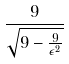Convert formula to latex. <formula><loc_0><loc_0><loc_500><loc_500>\frac { 9 } { \sqrt { 9 - \frac { 9 } { \epsilon ^ { 2 } } } }</formula> 